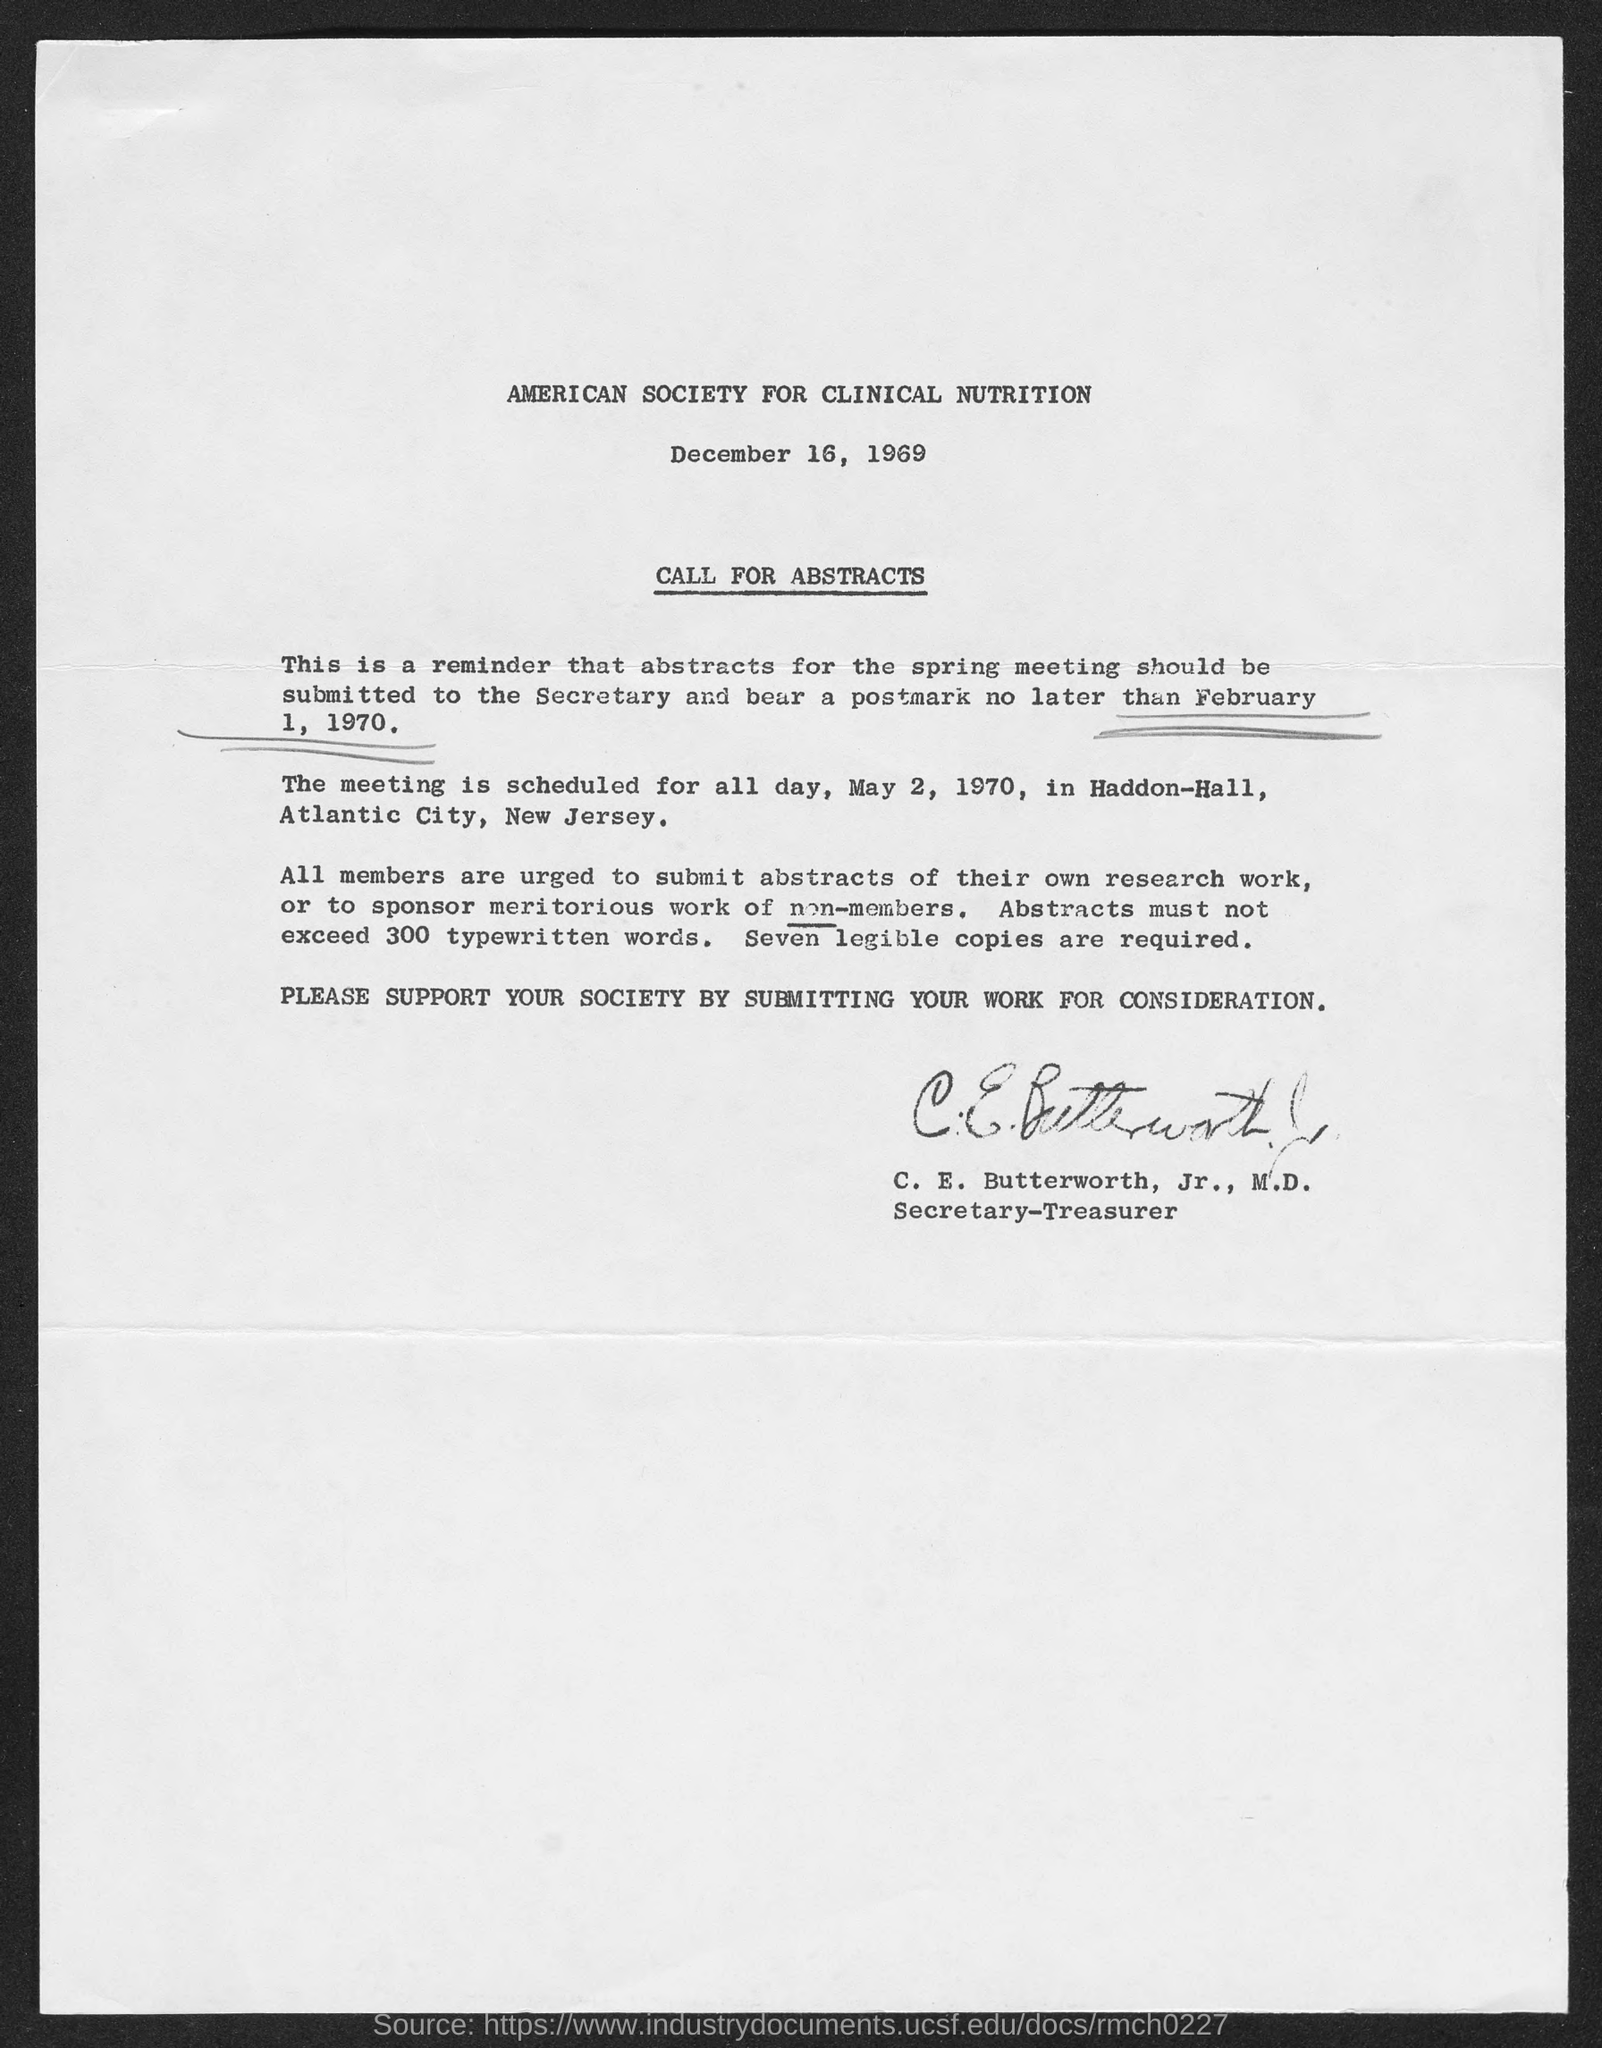Who has signed the document?
Provide a succinct answer. C.E. Butterworth. What is the designation of C. E. Butterworth, Jr., M.D.?
Provide a short and direct response. Secretary-Treasurer. How many legible copies of abstracts are required?
Give a very brief answer. Seven legible copies are required. How many words the abstracts must not exceed?
Offer a terse response. 300 typewritten words. 